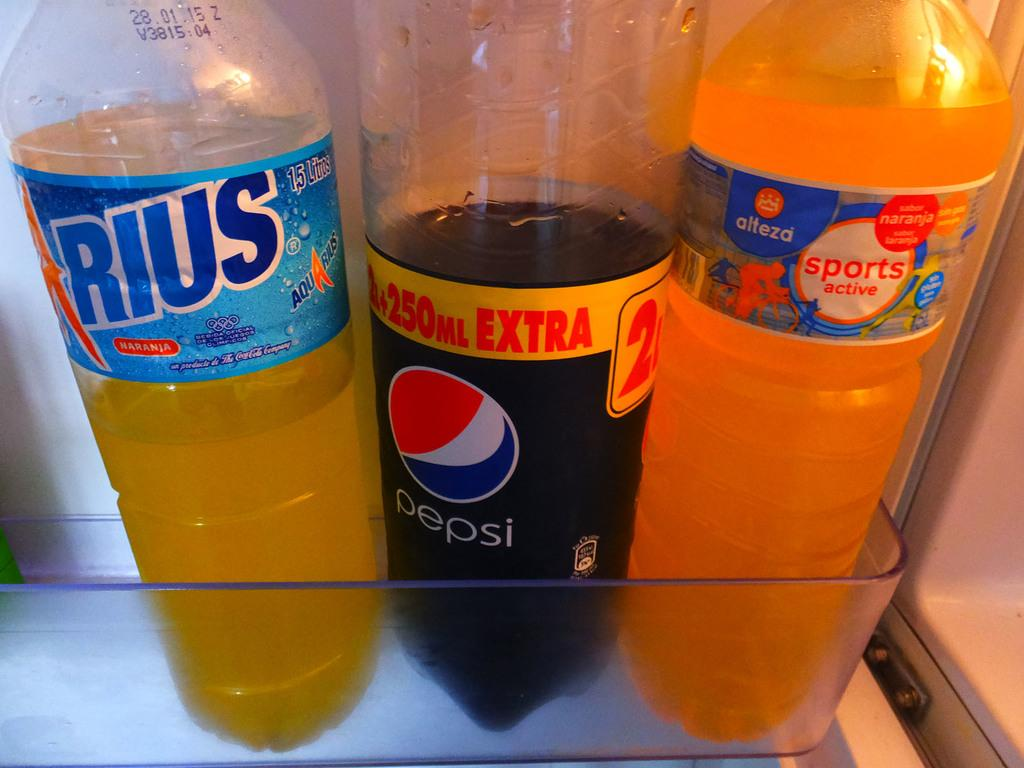<image>
Give a short and clear explanation of the subsequent image. Rius bottle drink, Pepsi bottle drink, and a Sports active bottle drink in a fridge. 